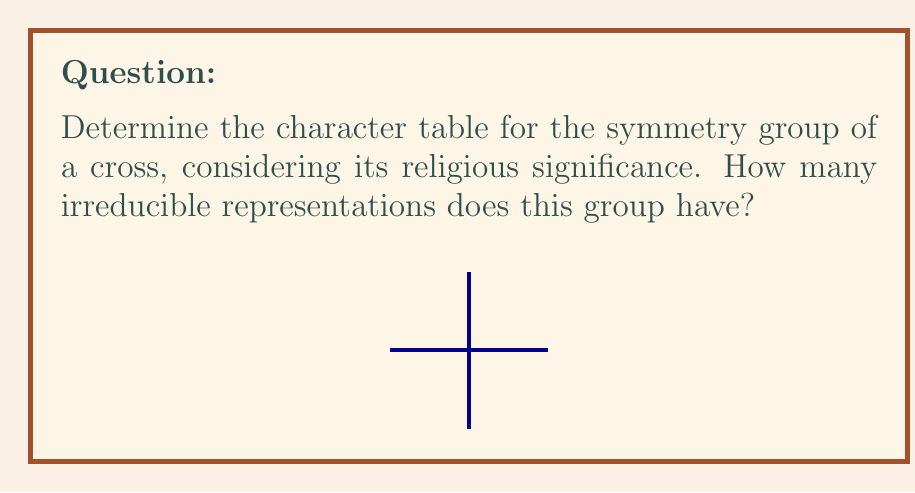Teach me how to tackle this problem. Let's approach this step-by-step:

1) First, we need to identify the symmetry group of a cross. The cross has the following symmetries:
   - Identity (E)
   - 180° rotation (C2)
   - Two reflections across vertical and horizontal axes (σv and σh)

   This group is isomorphic to the Klein four-group, V4, or C2 × C2.

2) The group has 4 elements, so it will have 4 conjugacy classes (each element is in its own class) and 4 irreducible representations.

3) We can label the conjugacy classes:
   C1 = {E}, C2 = {C2}, C3 = {σv}, C4 = {σh}

4) The character table will be a 4x4 table. We know that:
   - The first row will be all 1's (trivial representation)
   - The first column will be the dimensions of the representations (all 1 for this group)

5) Using the orthogonality of characters and the fact that the sum of squares of dimensions must equal the order of the group, we can deduce that all representations are 1-dimensional.

6) The complete character table:

   $$
   \begin{array}{c|cccc}
    V4 & E & C2 & \sigma_v & \sigma_h \\
   \hline
   \chi_1 & 1 & 1 & 1 & 1 \\
   \chi_2 & 1 & 1 & -1 & -1 \\
   \chi_3 & 1 & -1 & 1 & -1 \\
   \chi_4 & 1 & -1 & -1 & 1
   \end{array}
   $$

7) The number of irreducible representations is equal to the number of rows in the character table, which is 4.

This symmetry group, representing the cross, a symbol central to Catholic faith, has 4 irreducible representations, which could be seen as reflecting the 4 evangelists or the 4 cardinal virtues in Catholic tradition.
Answer: 4 irreducible representations 